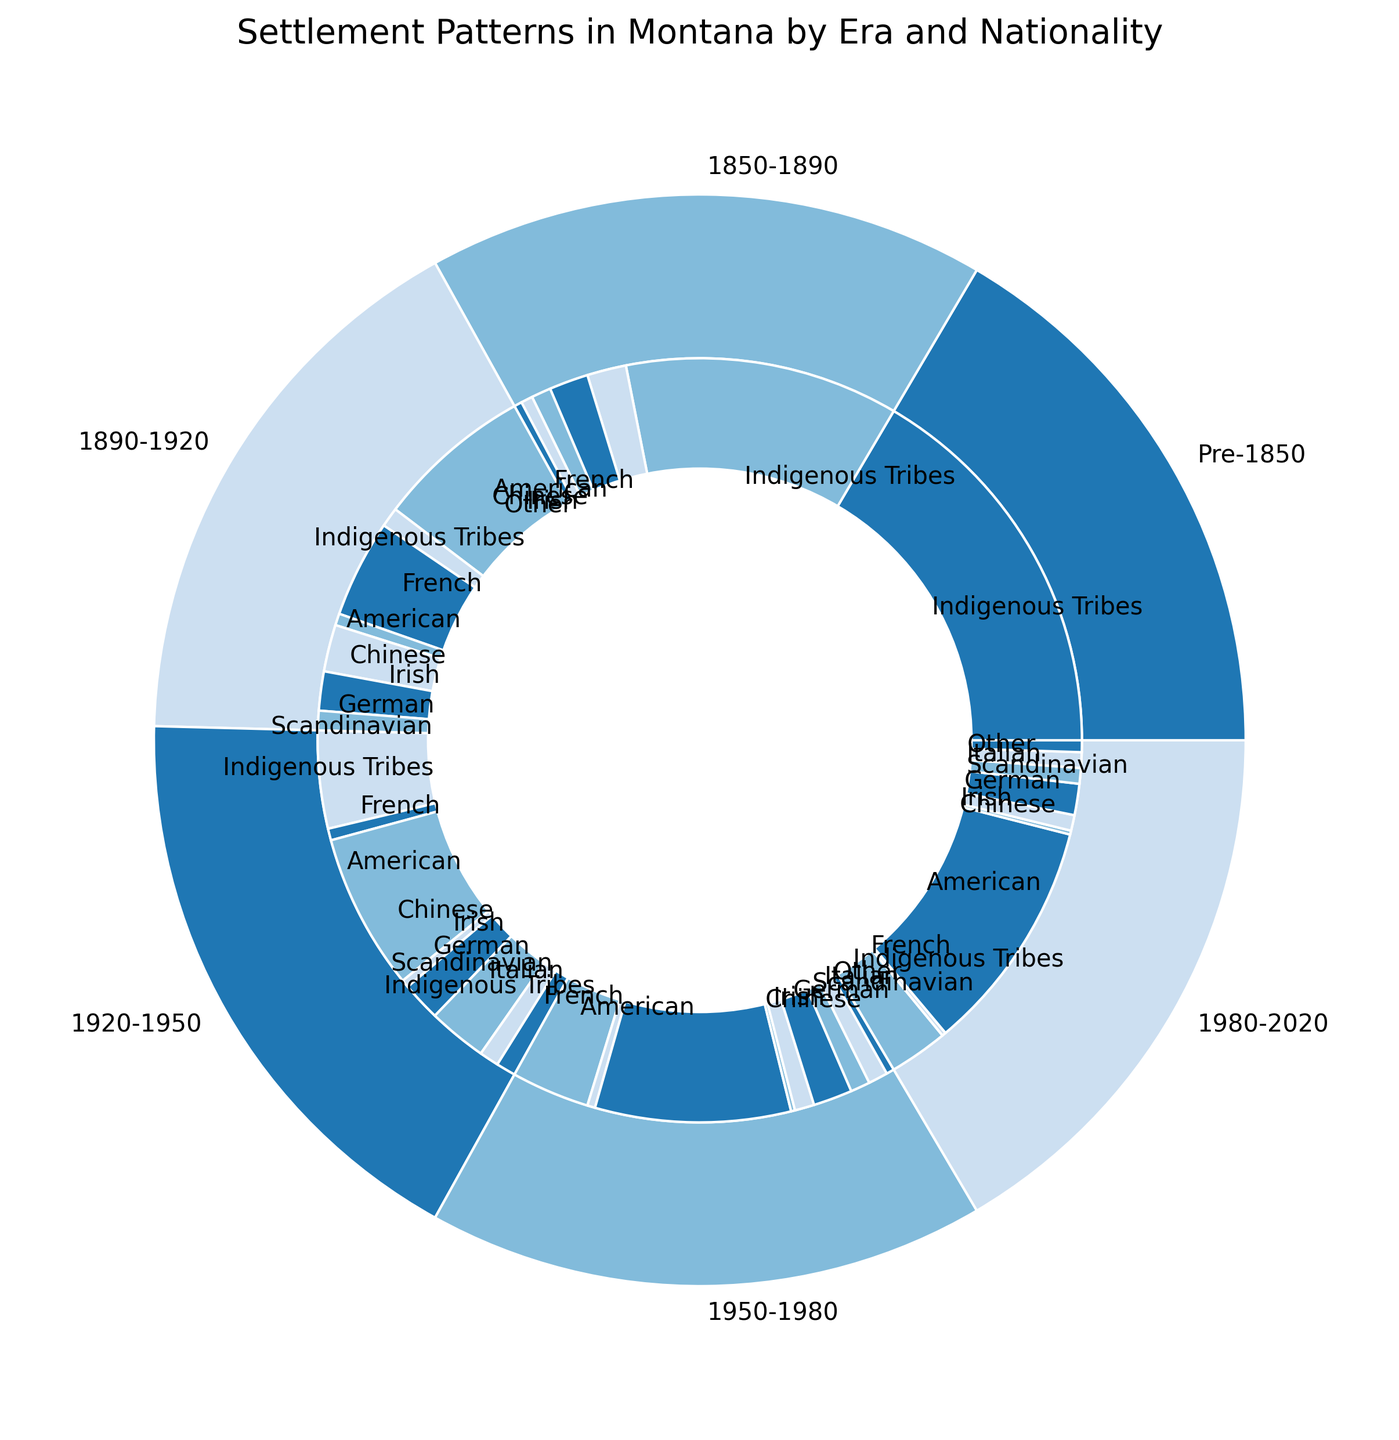How did the percentage of Indigenous Tribes change from 1850-1890 to 1980-2020? To find the change, look at the pie segments for "Indigenous Tribes." In 1850-1890, they constituted 70%. In 1980-2020, it was 15%. Calculate the difference: 70% - 15% = 55%.
Answer: Decreased by 55% Which nationality had the highest percentage increase in presence from 1850-1890 to 1950-1980? First, identify the segments representing non-indigenous nationalities between 1850-1890 and 1950-1980. Americans increased from 10% to 50%. Comparing increases, Americans had the highest percentage increase.
Answer: Americans How did the proportion of Germans change from 1890-1920 to 1920-1950? Look at the percentage segments for "German" in the respective eras: 10% in 1890-1920 and 15% in 1920-1950. Calculate the difference: 15% - 10% = 5%.
Answer: Increased by 5% In which era did "Irish" settlers form exactly 10% of the population? Identify the era with a pie segment labeled "Irish" corresponding to 10%. This appears in 1920-1950.
Answer: 1920-1950 Which era had the most diverse set of nationalities, based on the number of distinct segments in the inner ring? Count the number of unique segments in each era's inner ring. The era from 1920-1950 has the most diverse set of segments: Indigenous Tribes, French, American, Chinese, Irish, German, Scandinavian, Italian.
Answer: 1920-1950 By how much did the percentage of "French" settlers decrease from 1890-1920 to 1980-2020? Compare the "French" segments between the two eras: 5% in 1890-1920 and 1% in 1980-2020. Calculate the difference: 5% - 1% = 4%.
Answer: Decreased by 4% What is the combined percentage of "Scandinavian" settlers across all eras? Identify the "Scandinavian" segments in each era: 1890-1920 (5%), 1920-1950 (5%), 1950-1980 (5%), 1980-2020 (4%). Sum these percentages: 5% + 5% + 5% + 4% = 19%.
Answer: 19% Which era had the lowest percentage of "Indigenous Tribes"? Identify the smallest segment labeled "Indigenous Tribes" across all eras. The smallest segment is in 1980-2020 at 15%.
Answer: 1980-2020 How did the total presence of "Other" nationalities change from the era 1850-1890 to 1980-2020? Compare the "Other" segments in the two eras: 1850-1890 (2%) and 1980-2020 (3%). Calculate the difference: 3% - 2% = 1%.
Answer: Increased by 1% What percentage of the total population did "Chinese" settlers constitute in 1920-1950? Identify the percentage label for "Chinese" in the era 1920-1950, which is 2%.
Answer: 2% 